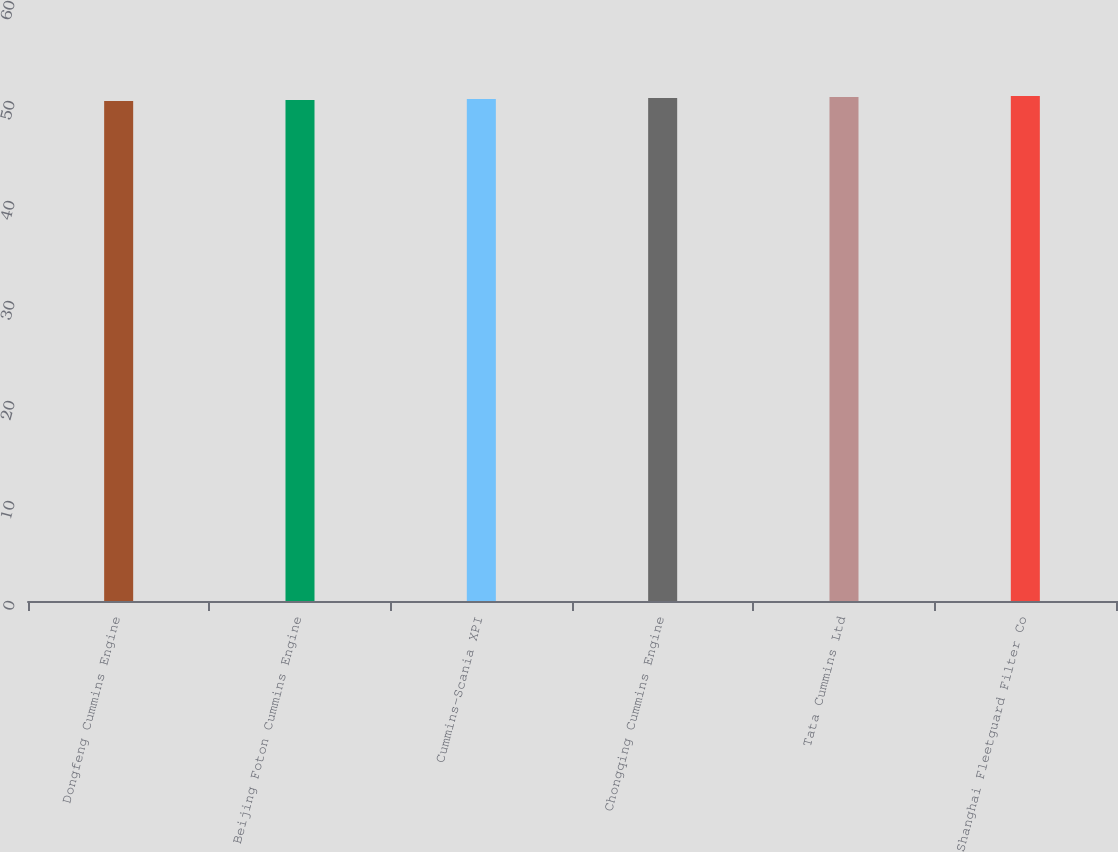Convert chart to OTSL. <chart><loc_0><loc_0><loc_500><loc_500><bar_chart><fcel>Dongfeng Cummins Engine<fcel>Beijing Foton Cummins Engine<fcel>Cummins-Scania XPI<fcel>Chongqing Cummins Engine<fcel>Tata Cummins Ltd<fcel>Shanghai Fleetguard Filter Co<nl><fcel>50<fcel>50.1<fcel>50.2<fcel>50.3<fcel>50.4<fcel>50.5<nl></chart> 